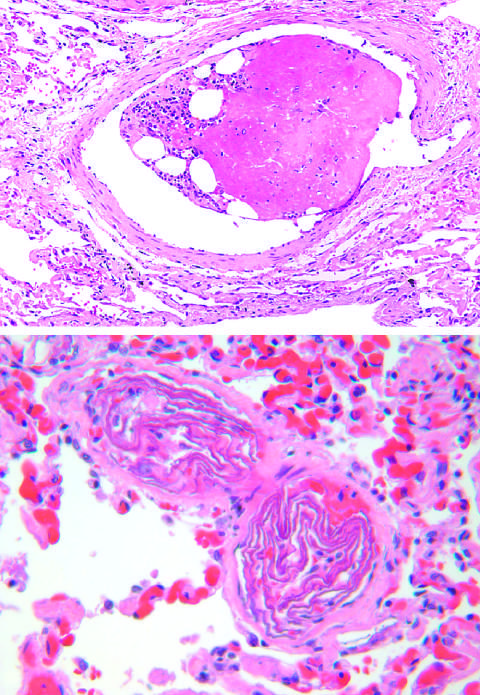what is composed of hematopoietic marrow and marrow fat cells attached to a thrombus?
Answer the question using a single word or phrase. The embolus 